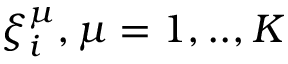Convert formula to latex. <formula><loc_0><loc_0><loc_500><loc_500>\xi _ { i } ^ { \mu } , \mu = 1 , . . , K</formula> 